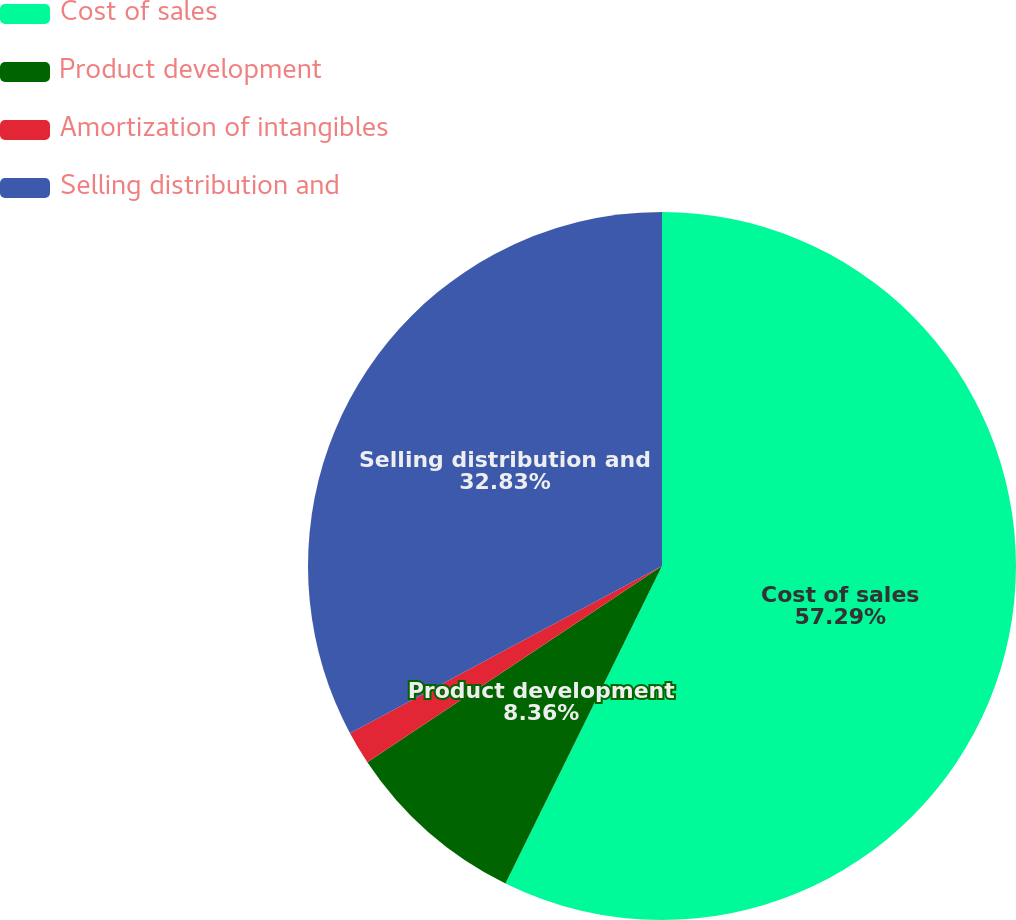<chart> <loc_0><loc_0><loc_500><loc_500><pie_chart><fcel>Cost of sales<fcel>Product development<fcel>Amortization of intangibles<fcel>Selling distribution and<nl><fcel>57.29%<fcel>8.36%<fcel>1.52%<fcel>32.83%<nl></chart> 